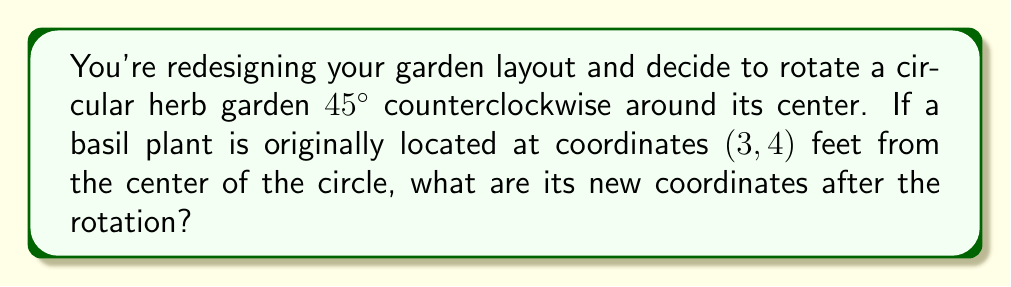Can you answer this question? To solve this problem, we'll use the rotation matrix for a counterclockwise rotation. The steps are as follows:

1) The rotation matrix for a counterclockwise rotation by angle θ is:
   $$R(\theta) = \begin{bmatrix} \cos\theta & -\sin\theta \\ \sin\theta & \cos\theta \end{bmatrix}$$

2) In this case, θ = 45° = π/4 radians. We need to calculate:
   $$\begin{bmatrix} \cos(π/4) & -\sin(π/4) \\ \sin(π/4) & \cos(π/4) \end{bmatrix} \begin{bmatrix} 3 \\ 4 \end{bmatrix}$$

3) We know that $\cos(45°) = \sin(45°) = \frac{1}{\sqrt{2}} \approx 0.7071$

4) Substituting these values:
   $$\begin{bmatrix} 0.7071 & -0.7071 \\ 0.7071 & 0.7071 \end{bmatrix} \begin{bmatrix} 3 \\ 4 \end{bmatrix}$$

5) Multiplying the matrices:
   $$\begin{bmatrix} (0.7071 * 3) + (-0.7071 * 4) \\ (0.7071 * 3) + (0.7071 * 4) \end{bmatrix}$$

6) Simplifying:
   $$\begin{bmatrix} 2.1213 - 2.8284 \\ 2.1213 + 2.8284 \end{bmatrix} = \begin{bmatrix} -0.7071 \\ 4.9497 \end{bmatrix}$$

7) Rounding to two decimal places:
   $$\begin{bmatrix} -0.71 \\ 4.95 \end{bmatrix}$$

Therefore, the new coordinates of the basil plant after rotation are approximately (-0.71, 4.95) feet from the center of the circular herb garden.
Answer: (-0.71, 4.95) feet 